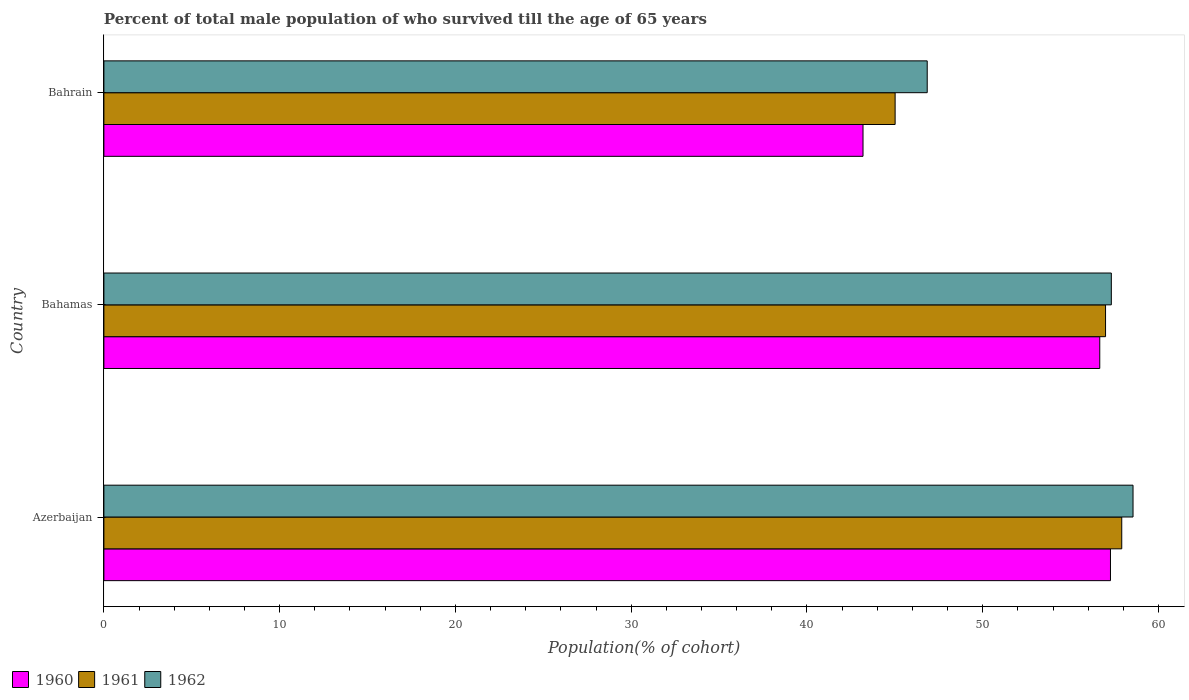How many groups of bars are there?
Ensure brevity in your answer.  3. Are the number of bars per tick equal to the number of legend labels?
Keep it short and to the point. Yes. How many bars are there on the 2nd tick from the bottom?
Make the answer very short. 3. What is the label of the 1st group of bars from the top?
Provide a short and direct response. Bahrain. What is the percentage of total male population who survived till the age of 65 years in 1962 in Bahrain?
Offer a very short reply. 46.84. Across all countries, what is the maximum percentage of total male population who survived till the age of 65 years in 1960?
Your answer should be very brief. 57.27. Across all countries, what is the minimum percentage of total male population who survived till the age of 65 years in 1962?
Give a very brief answer. 46.84. In which country was the percentage of total male population who survived till the age of 65 years in 1962 maximum?
Provide a succinct answer. Azerbaijan. In which country was the percentage of total male population who survived till the age of 65 years in 1960 minimum?
Provide a short and direct response. Bahrain. What is the total percentage of total male population who survived till the age of 65 years in 1961 in the graph?
Provide a succinct answer. 159.92. What is the difference between the percentage of total male population who survived till the age of 65 years in 1961 in Azerbaijan and that in Bahamas?
Your answer should be compact. 0.92. What is the difference between the percentage of total male population who survived till the age of 65 years in 1962 in Bahamas and the percentage of total male population who survived till the age of 65 years in 1960 in Bahrain?
Offer a very short reply. 14.13. What is the average percentage of total male population who survived till the age of 65 years in 1960 per country?
Provide a short and direct response. 52.37. What is the difference between the percentage of total male population who survived till the age of 65 years in 1961 and percentage of total male population who survived till the age of 65 years in 1960 in Azerbaijan?
Make the answer very short. 0.64. In how many countries, is the percentage of total male population who survived till the age of 65 years in 1962 greater than 42 %?
Ensure brevity in your answer.  3. What is the ratio of the percentage of total male population who survived till the age of 65 years in 1962 in Azerbaijan to that in Bahamas?
Your response must be concise. 1.02. What is the difference between the highest and the second highest percentage of total male population who survived till the age of 65 years in 1962?
Provide a succinct answer. 1.24. What is the difference between the highest and the lowest percentage of total male population who survived till the age of 65 years in 1960?
Keep it short and to the point. 14.08. In how many countries, is the percentage of total male population who survived till the age of 65 years in 1962 greater than the average percentage of total male population who survived till the age of 65 years in 1962 taken over all countries?
Offer a very short reply. 2. What does the 3rd bar from the top in Bahamas represents?
Offer a very short reply. 1960. Is it the case that in every country, the sum of the percentage of total male population who survived till the age of 65 years in 1960 and percentage of total male population who survived till the age of 65 years in 1962 is greater than the percentage of total male population who survived till the age of 65 years in 1961?
Your answer should be very brief. Yes. How many countries are there in the graph?
Provide a short and direct response. 3. Does the graph contain grids?
Offer a terse response. No. How many legend labels are there?
Keep it short and to the point. 3. What is the title of the graph?
Provide a short and direct response. Percent of total male population of who survived till the age of 65 years. Does "1987" appear as one of the legend labels in the graph?
Your answer should be very brief. No. What is the label or title of the X-axis?
Make the answer very short. Population(% of cohort). What is the label or title of the Y-axis?
Your answer should be very brief. Country. What is the Population(% of cohort) of 1960 in Azerbaijan?
Provide a short and direct response. 57.27. What is the Population(% of cohort) in 1961 in Azerbaijan?
Provide a succinct answer. 57.91. What is the Population(% of cohort) of 1962 in Azerbaijan?
Your answer should be compact. 58.55. What is the Population(% of cohort) in 1960 in Bahamas?
Ensure brevity in your answer.  56.66. What is the Population(% of cohort) of 1961 in Bahamas?
Provide a succinct answer. 56.99. What is the Population(% of cohort) in 1962 in Bahamas?
Your answer should be very brief. 57.32. What is the Population(% of cohort) of 1960 in Bahrain?
Provide a short and direct response. 43.19. What is the Population(% of cohort) in 1961 in Bahrain?
Provide a succinct answer. 45.02. What is the Population(% of cohort) in 1962 in Bahrain?
Offer a terse response. 46.84. Across all countries, what is the maximum Population(% of cohort) in 1960?
Your answer should be compact. 57.27. Across all countries, what is the maximum Population(% of cohort) of 1961?
Offer a very short reply. 57.91. Across all countries, what is the maximum Population(% of cohort) in 1962?
Your answer should be compact. 58.55. Across all countries, what is the minimum Population(% of cohort) of 1960?
Offer a terse response. 43.19. Across all countries, what is the minimum Population(% of cohort) of 1961?
Offer a very short reply. 45.02. Across all countries, what is the minimum Population(% of cohort) of 1962?
Give a very brief answer. 46.84. What is the total Population(% of cohort) of 1960 in the graph?
Give a very brief answer. 157.12. What is the total Population(% of cohort) in 1961 in the graph?
Ensure brevity in your answer.  159.92. What is the total Population(% of cohort) in 1962 in the graph?
Provide a short and direct response. 162.71. What is the difference between the Population(% of cohort) of 1960 in Azerbaijan and that in Bahamas?
Give a very brief answer. 0.61. What is the difference between the Population(% of cohort) of 1961 in Azerbaijan and that in Bahamas?
Give a very brief answer. 0.92. What is the difference between the Population(% of cohort) of 1962 in Azerbaijan and that in Bahamas?
Your response must be concise. 1.24. What is the difference between the Population(% of cohort) in 1960 in Azerbaijan and that in Bahrain?
Keep it short and to the point. 14.08. What is the difference between the Population(% of cohort) of 1961 in Azerbaijan and that in Bahrain?
Keep it short and to the point. 12.89. What is the difference between the Population(% of cohort) of 1962 in Azerbaijan and that in Bahrain?
Your answer should be very brief. 11.71. What is the difference between the Population(% of cohort) in 1960 in Bahamas and that in Bahrain?
Your answer should be compact. 13.47. What is the difference between the Population(% of cohort) in 1961 in Bahamas and that in Bahrain?
Keep it short and to the point. 11.97. What is the difference between the Population(% of cohort) of 1962 in Bahamas and that in Bahrain?
Offer a terse response. 10.47. What is the difference between the Population(% of cohort) of 1960 in Azerbaijan and the Population(% of cohort) of 1961 in Bahamas?
Provide a short and direct response. 0.28. What is the difference between the Population(% of cohort) in 1960 in Azerbaijan and the Population(% of cohort) in 1962 in Bahamas?
Provide a short and direct response. -0.05. What is the difference between the Population(% of cohort) in 1961 in Azerbaijan and the Population(% of cohort) in 1962 in Bahamas?
Your answer should be very brief. 0.59. What is the difference between the Population(% of cohort) of 1960 in Azerbaijan and the Population(% of cohort) of 1961 in Bahrain?
Offer a very short reply. 12.25. What is the difference between the Population(% of cohort) of 1960 in Azerbaijan and the Population(% of cohort) of 1962 in Bahrain?
Your answer should be compact. 10.43. What is the difference between the Population(% of cohort) of 1961 in Azerbaijan and the Population(% of cohort) of 1962 in Bahrain?
Offer a terse response. 11.07. What is the difference between the Population(% of cohort) in 1960 in Bahamas and the Population(% of cohort) in 1961 in Bahrain?
Keep it short and to the point. 11.64. What is the difference between the Population(% of cohort) of 1960 in Bahamas and the Population(% of cohort) of 1962 in Bahrain?
Offer a very short reply. 9.82. What is the difference between the Population(% of cohort) of 1961 in Bahamas and the Population(% of cohort) of 1962 in Bahrain?
Your answer should be compact. 10.15. What is the average Population(% of cohort) in 1960 per country?
Give a very brief answer. 52.37. What is the average Population(% of cohort) of 1961 per country?
Keep it short and to the point. 53.31. What is the average Population(% of cohort) of 1962 per country?
Make the answer very short. 54.24. What is the difference between the Population(% of cohort) in 1960 and Population(% of cohort) in 1961 in Azerbaijan?
Provide a short and direct response. -0.64. What is the difference between the Population(% of cohort) of 1960 and Population(% of cohort) of 1962 in Azerbaijan?
Ensure brevity in your answer.  -1.28. What is the difference between the Population(% of cohort) in 1961 and Population(% of cohort) in 1962 in Azerbaijan?
Give a very brief answer. -0.64. What is the difference between the Population(% of cohort) in 1960 and Population(% of cohort) in 1961 in Bahamas?
Ensure brevity in your answer.  -0.33. What is the difference between the Population(% of cohort) of 1960 and Population(% of cohort) of 1962 in Bahamas?
Offer a terse response. -0.66. What is the difference between the Population(% of cohort) in 1961 and Population(% of cohort) in 1962 in Bahamas?
Make the answer very short. -0.33. What is the difference between the Population(% of cohort) in 1960 and Population(% of cohort) in 1961 in Bahrain?
Ensure brevity in your answer.  -1.83. What is the difference between the Population(% of cohort) of 1960 and Population(% of cohort) of 1962 in Bahrain?
Provide a succinct answer. -3.65. What is the difference between the Population(% of cohort) in 1961 and Population(% of cohort) in 1962 in Bahrain?
Ensure brevity in your answer.  -1.83. What is the ratio of the Population(% of cohort) in 1960 in Azerbaijan to that in Bahamas?
Offer a very short reply. 1.01. What is the ratio of the Population(% of cohort) in 1961 in Azerbaijan to that in Bahamas?
Keep it short and to the point. 1.02. What is the ratio of the Population(% of cohort) in 1962 in Azerbaijan to that in Bahamas?
Keep it short and to the point. 1.02. What is the ratio of the Population(% of cohort) of 1960 in Azerbaijan to that in Bahrain?
Ensure brevity in your answer.  1.33. What is the ratio of the Population(% of cohort) of 1961 in Azerbaijan to that in Bahrain?
Ensure brevity in your answer.  1.29. What is the ratio of the Population(% of cohort) in 1962 in Azerbaijan to that in Bahrain?
Your response must be concise. 1.25. What is the ratio of the Population(% of cohort) in 1960 in Bahamas to that in Bahrain?
Offer a very short reply. 1.31. What is the ratio of the Population(% of cohort) in 1961 in Bahamas to that in Bahrain?
Offer a terse response. 1.27. What is the ratio of the Population(% of cohort) in 1962 in Bahamas to that in Bahrain?
Your answer should be very brief. 1.22. What is the difference between the highest and the second highest Population(% of cohort) in 1960?
Make the answer very short. 0.61. What is the difference between the highest and the second highest Population(% of cohort) in 1961?
Ensure brevity in your answer.  0.92. What is the difference between the highest and the second highest Population(% of cohort) of 1962?
Give a very brief answer. 1.24. What is the difference between the highest and the lowest Population(% of cohort) in 1960?
Give a very brief answer. 14.08. What is the difference between the highest and the lowest Population(% of cohort) in 1961?
Provide a succinct answer. 12.89. What is the difference between the highest and the lowest Population(% of cohort) in 1962?
Provide a short and direct response. 11.71. 